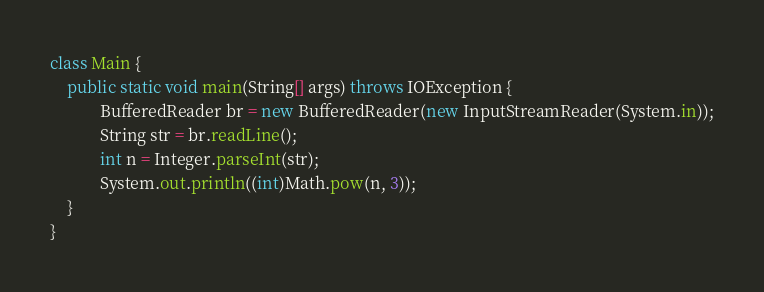Convert code to text. <code><loc_0><loc_0><loc_500><loc_500><_Java_>class Main {
	public static void main(String[] args) throws IOException {
			BufferedReader br = new BufferedReader(new InputStreamReader(System.in));
			String str = br.readLine();
			int n = Integer.parseInt(str);
			System.out.println((int)Math.pow(n, 3));
	}
}</code> 